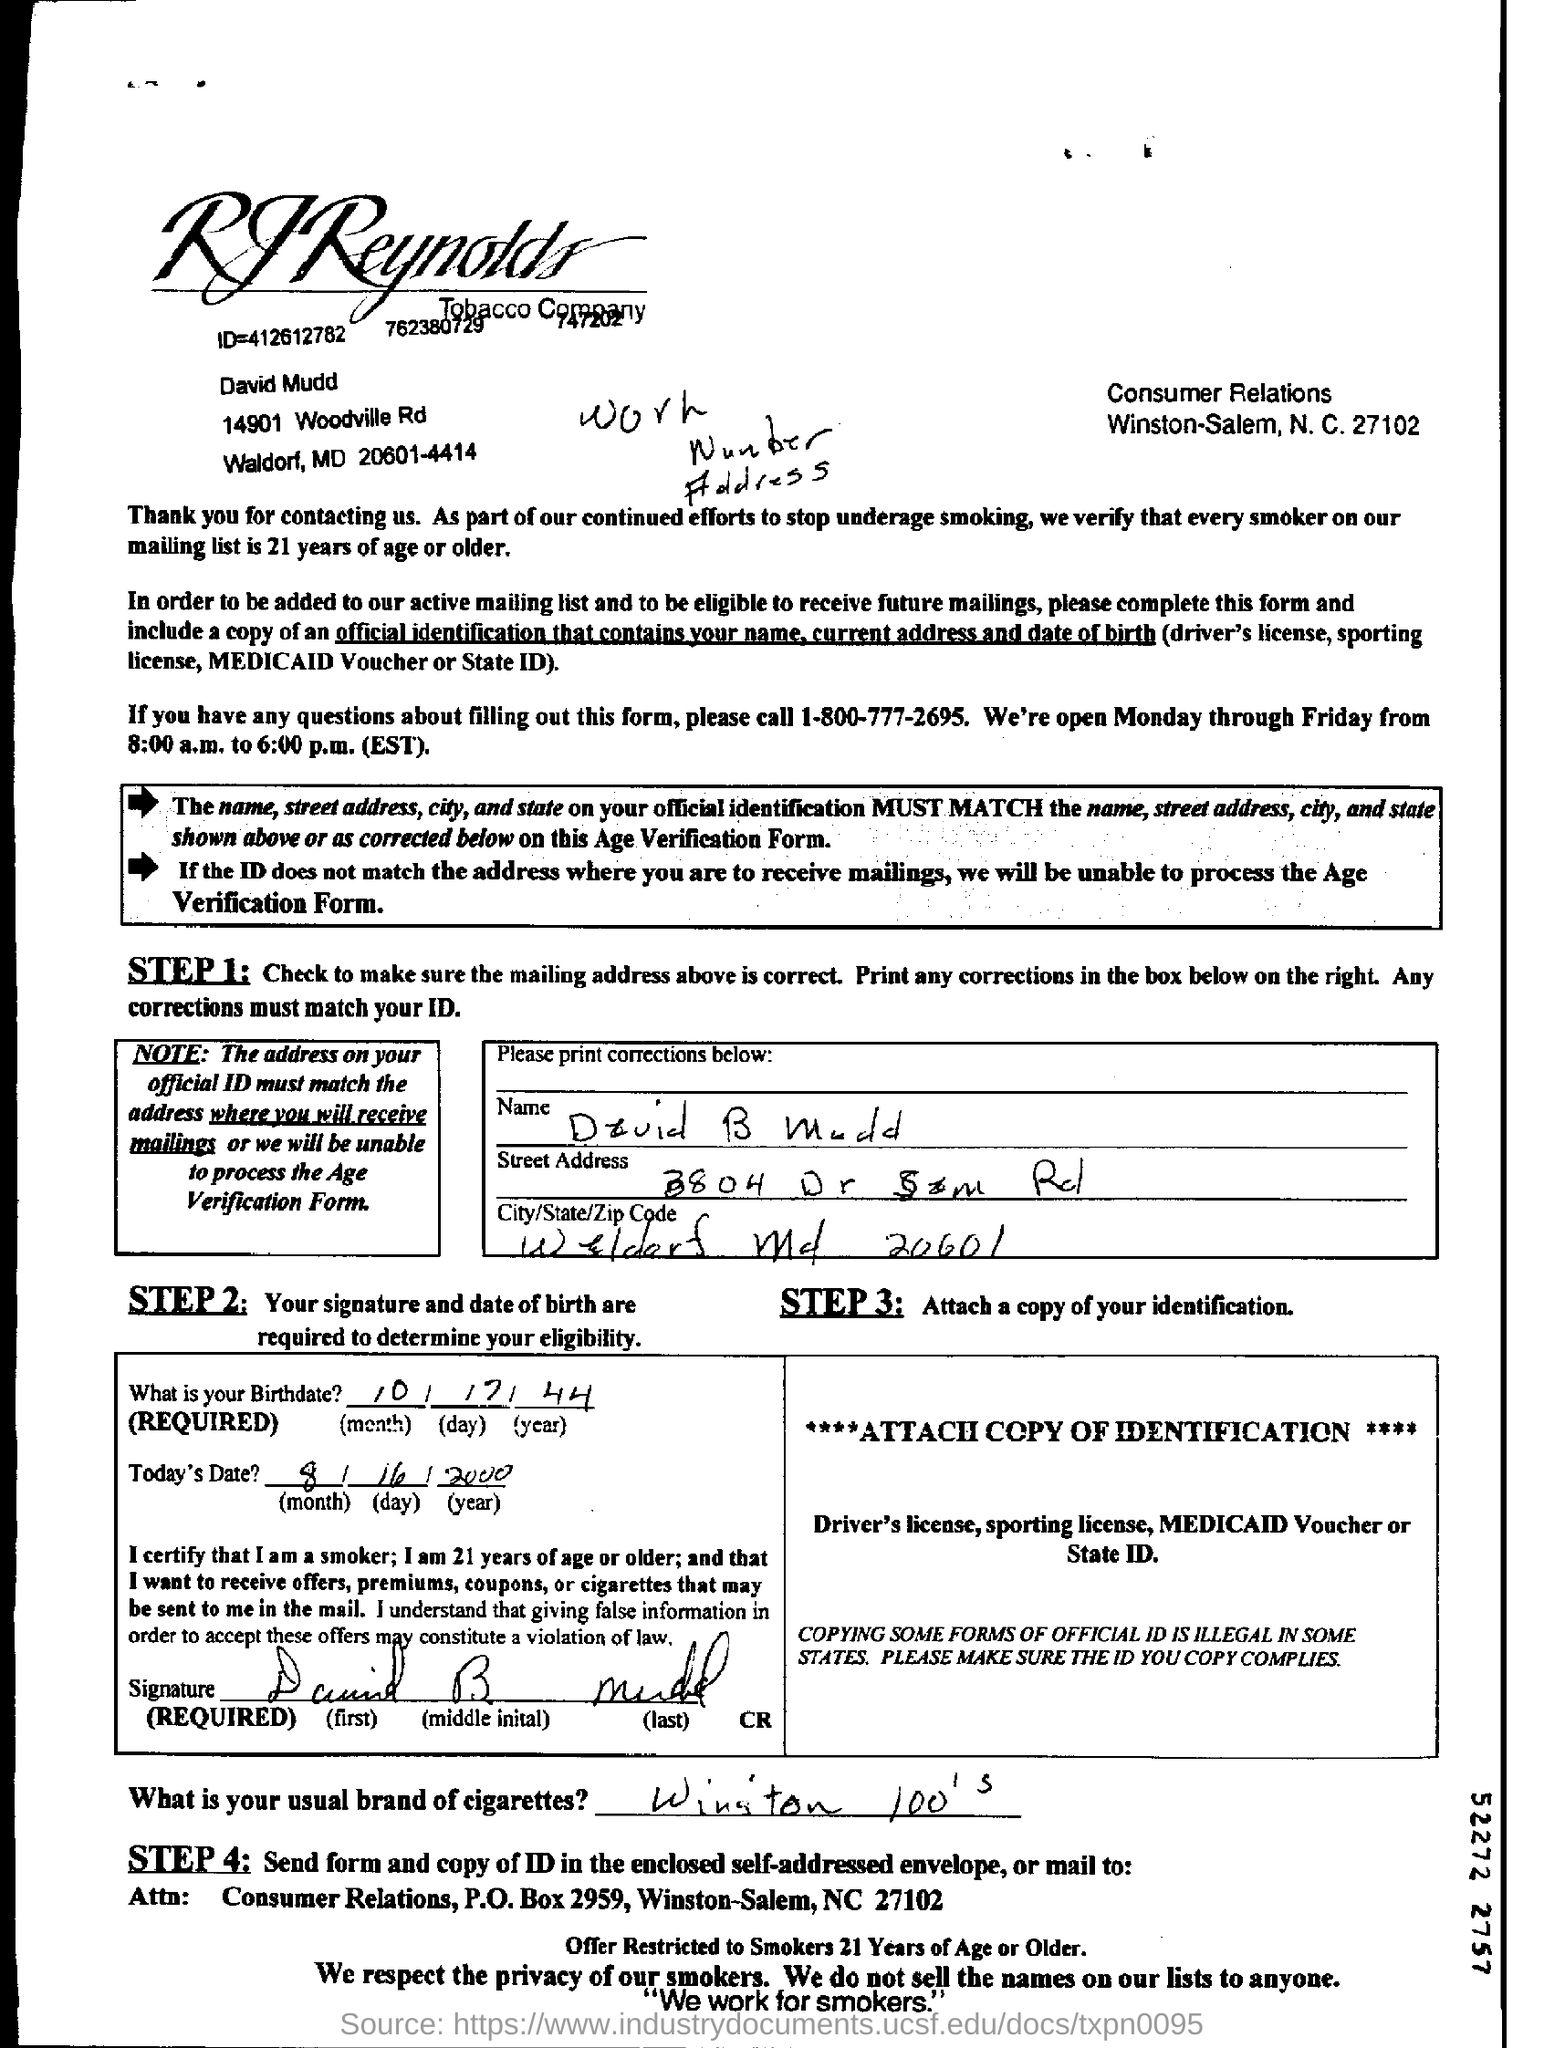What is the name of the company?
Your answer should be very brief. RJReynolds tobacco company. What is the n.c. number?
Offer a very short reply. 27102. Which number is to be dialled if you have any questions?
Keep it short and to the point. 1-800-777-2695. What is the age limit for every smoker on the mailing list?
Provide a succinct answer. 21 years of age or older. What is the birthdate?
Give a very brief answer. 10/17/44. What is today's date?
Ensure brevity in your answer.  8/16/2000. 